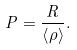Convert formula to latex. <formula><loc_0><loc_0><loc_500><loc_500>P = \frac { R } { \left \langle \rho \right \rangle } .</formula> 